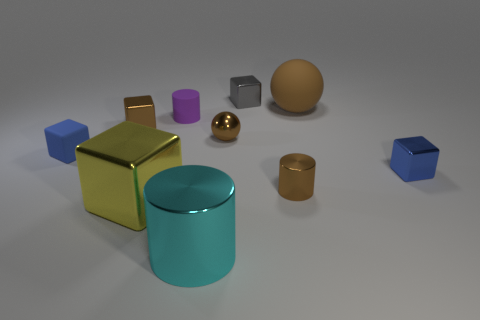There is a tiny blue thing that is on the left side of the small purple rubber object; is it the same shape as the small blue thing that is right of the matte ball? Yes, the tiny blue object on the left side of the small purple rubber object is indeed cube-shaped, just like the small blue cube situated to the right of the matte sphere. Both share the same geometric form. 